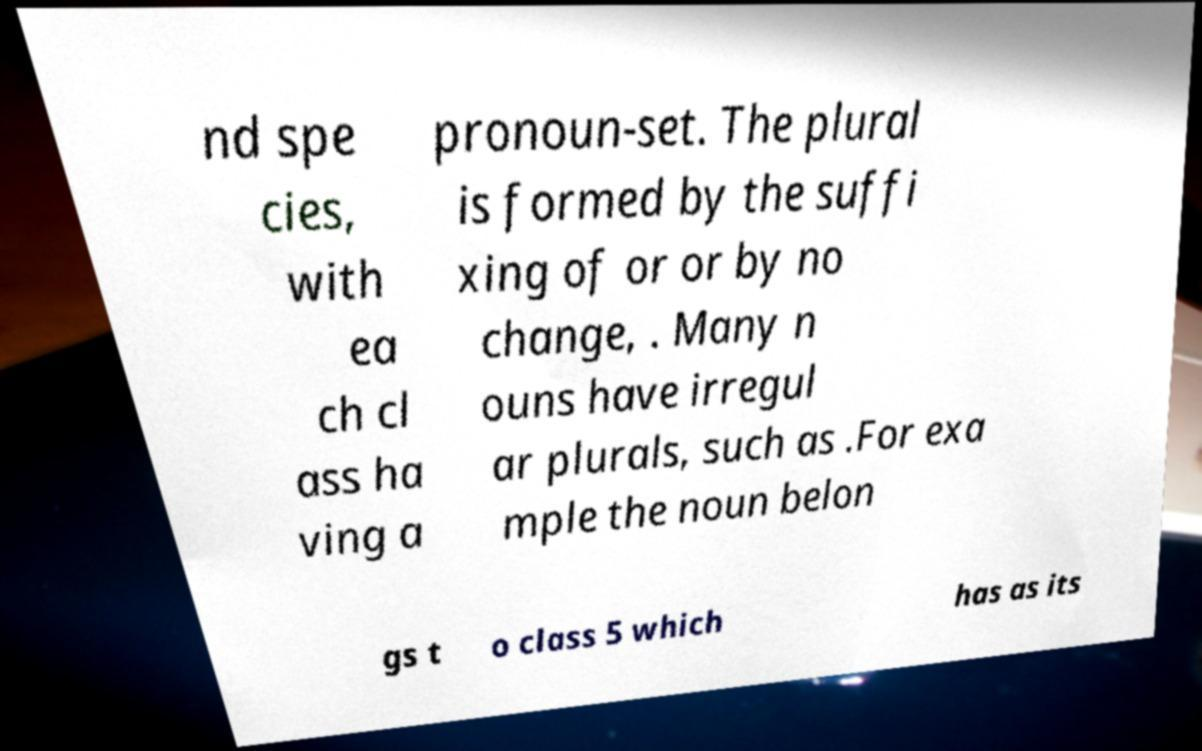I need the written content from this picture converted into text. Can you do that? nd spe cies, with ea ch cl ass ha ving a pronoun-set. The plural is formed by the suffi xing of or or by no change, . Many n ouns have irregul ar plurals, such as .For exa mple the noun belon gs t o class 5 which has as its 